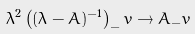Convert formula to latex. <formula><loc_0><loc_0><loc_500><loc_500>\lambda ^ { 2 } \left ( ( \lambda - A ) ^ { - 1 } \right ) _ { - } v \to A _ { - } v \,</formula> 